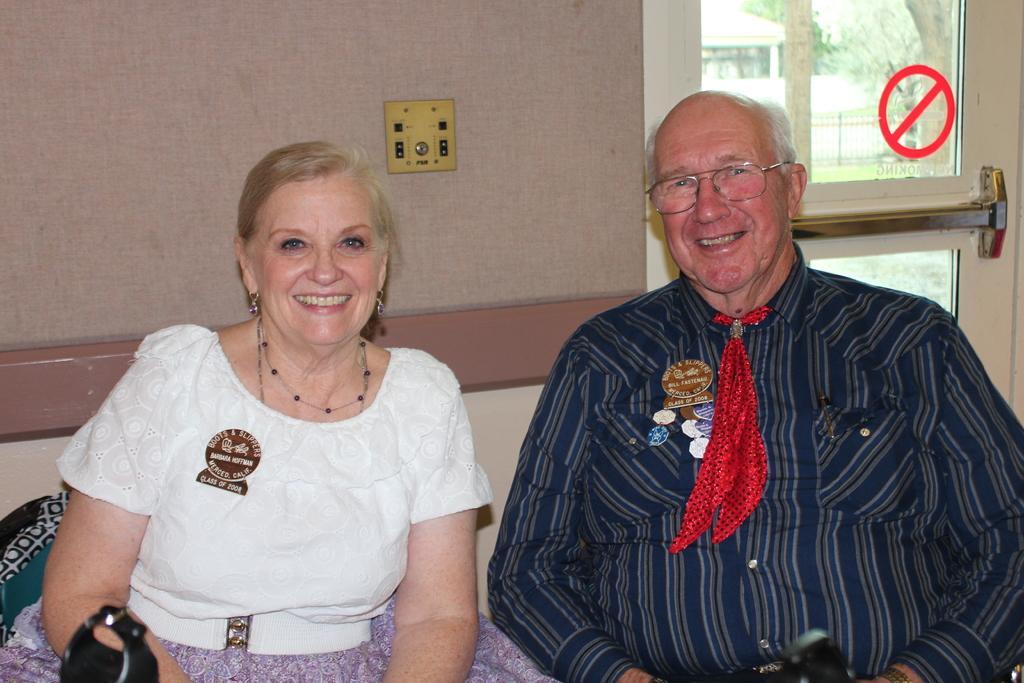Please provide a concise description of this image. There is a man and a woman sitting. Man is wearing a specs. In the back there is a wall. Also there is a glass door with a sign mark. 